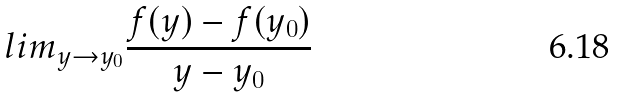Convert formula to latex. <formula><loc_0><loc_0><loc_500><loc_500>l i m _ { y \rightarrow y _ { 0 } } \frac { f ( y ) - f ( y _ { 0 } ) } { y - y _ { 0 } }</formula> 